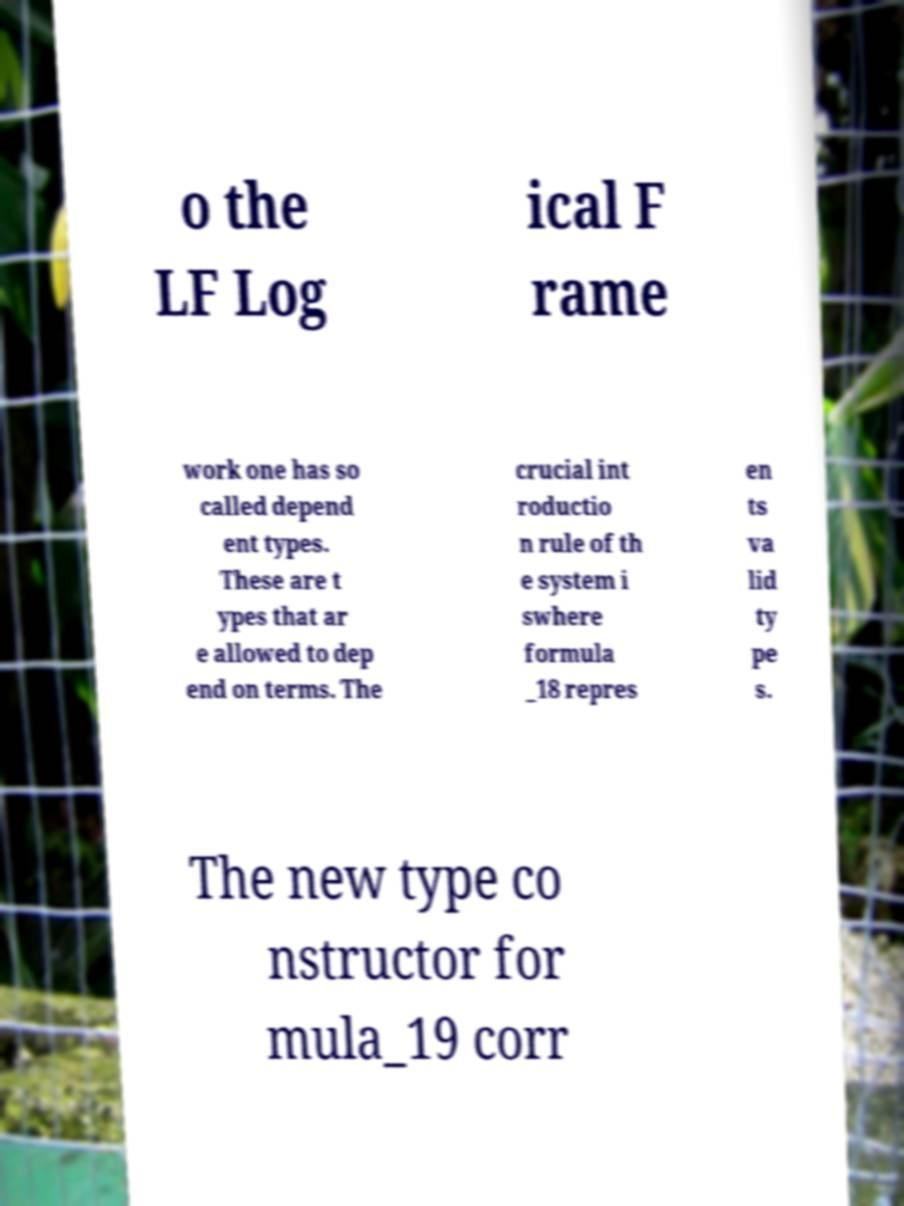Can you read and provide the text displayed in the image?This photo seems to have some interesting text. Can you extract and type it out for me? o the LF Log ical F rame work one has so called depend ent types. These are t ypes that ar e allowed to dep end on terms. The crucial int roductio n rule of th e system i swhere formula _18 repres en ts va lid ty pe s. The new type co nstructor for mula_19 corr 